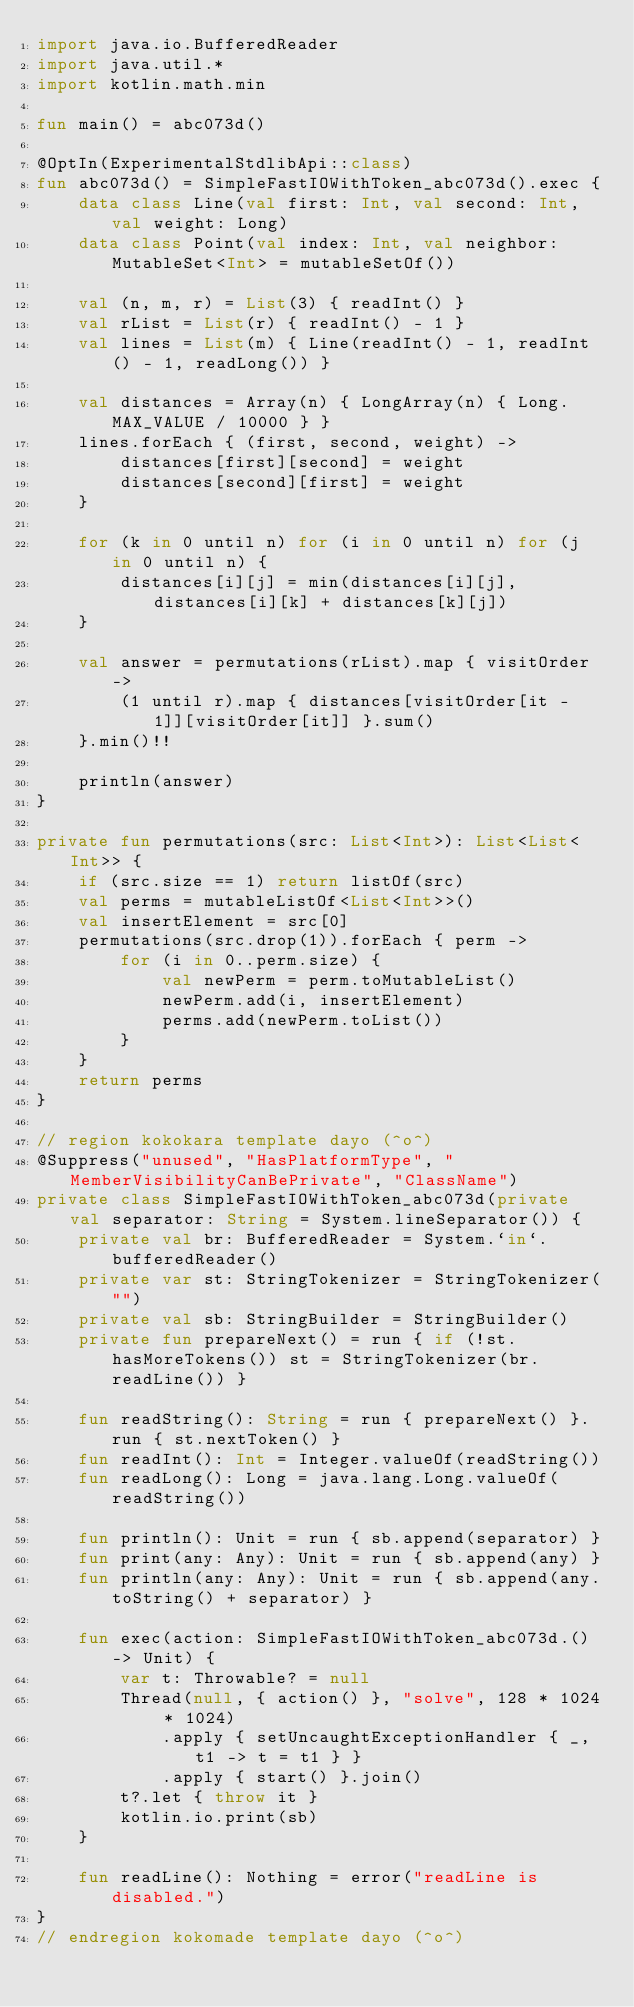Convert code to text. <code><loc_0><loc_0><loc_500><loc_500><_Kotlin_>import java.io.BufferedReader
import java.util.*
import kotlin.math.min

fun main() = abc073d()

@OptIn(ExperimentalStdlibApi::class)
fun abc073d() = SimpleFastIOWithToken_abc073d().exec {
    data class Line(val first: Int, val second: Int, val weight: Long)
    data class Point(val index: Int, val neighbor: MutableSet<Int> = mutableSetOf())

    val (n, m, r) = List(3) { readInt() }
    val rList = List(r) { readInt() - 1 }
    val lines = List(m) { Line(readInt() - 1, readInt() - 1, readLong()) }

    val distances = Array(n) { LongArray(n) { Long.MAX_VALUE / 10000 } }
    lines.forEach { (first, second, weight) ->
        distances[first][second] = weight
        distances[second][first] = weight
    }

    for (k in 0 until n) for (i in 0 until n) for (j in 0 until n) {
        distances[i][j] = min(distances[i][j], distances[i][k] + distances[k][j])
    }

    val answer = permutations(rList).map { visitOrder ->
        (1 until r).map { distances[visitOrder[it - 1]][visitOrder[it]] }.sum()
    }.min()!!

    println(answer)
}

private fun permutations(src: List<Int>): List<List<Int>> {
    if (src.size == 1) return listOf(src)
    val perms = mutableListOf<List<Int>>()
    val insertElement = src[0]
    permutations(src.drop(1)).forEach { perm ->
        for (i in 0..perm.size) {
            val newPerm = perm.toMutableList()
            newPerm.add(i, insertElement)
            perms.add(newPerm.toList())
        }
    }
    return perms
}

// region kokokara template dayo (^o^)
@Suppress("unused", "HasPlatformType", "MemberVisibilityCanBePrivate", "ClassName")
private class SimpleFastIOWithToken_abc073d(private val separator: String = System.lineSeparator()) {
    private val br: BufferedReader = System.`in`.bufferedReader()
    private var st: StringTokenizer = StringTokenizer("")
    private val sb: StringBuilder = StringBuilder()
    private fun prepareNext() = run { if (!st.hasMoreTokens()) st = StringTokenizer(br.readLine()) }

    fun readString(): String = run { prepareNext() }.run { st.nextToken() }
    fun readInt(): Int = Integer.valueOf(readString())
    fun readLong(): Long = java.lang.Long.valueOf(readString())

    fun println(): Unit = run { sb.append(separator) }
    fun print(any: Any): Unit = run { sb.append(any) }
    fun println(any: Any): Unit = run { sb.append(any.toString() + separator) }

    fun exec(action: SimpleFastIOWithToken_abc073d.() -> Unit) {
        var t: Throwable? = null
        Thread(null, { action() }, "solve", 128 * 1024 * 1024)
            .apply { setUncaughtExceptionHandler { _, t1 -> t = t1 } }
            .apply { start() }.join()
        t?.let { throw it }
        kotlin.io.print(sb)
    }

    fun readLine(): Nothing = error("readLine is disabled.")
}
// endregion kokomade template dayo (^o^)
</code> 